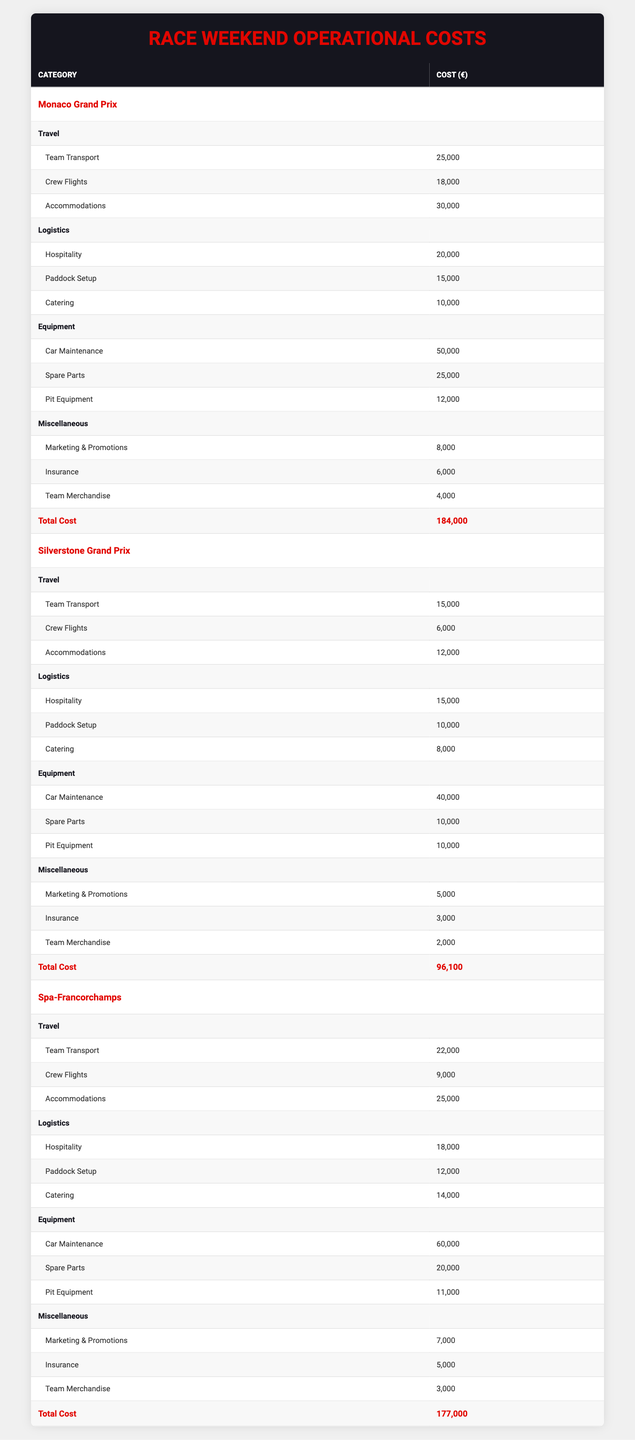What is the total cost for the Monaco Grand Prix? The total cost for the Monaco Grand Prix is listed in the table under the "Total Cost" row for that event, which shows 184000 euros.
Answer: 184000 euros What is the cost of crew flights for the Silverstone Grand Prix? The cost of crew flights is found in the "Travel" section for the Silverstone Grand Prix, and it is specifically listed as 6000 euros.
Answer: 6000 euros Which event has the highest total operational cost? By comparing the "Total Cost" values for each event, we see that the Monaco Grand Prix has the highest total at 184000 euros, while others are lower at 96100 euros and 177000 euros for the Silverstone Grand Prix and Spa-Francorchamps, respectively.
Answer: Monaco Grand Prix What is the combined cost for accommodations across all events? The accommodations costs are as follows: Monaco Grand Prix has 30000 euros, Silverstone Grand Prix has 12000 euros, and Spa-Francorchamps has 25000 euros. Adding these gives 30000 + 12000 + 25000 = 67000 euros for accommodations across all events.
Answer: 67000 euros Is the marketing and promotions cost for the Spa-Francorchamps higher than that for the Silverstone Grand Prix? The marketing and promotions cost for Spa-Francorchamps is 7000 euros, while for Silverstone Grand Prix, it is 5000 euros, indicating that Spa-Francorchamps has a higher cost.
Answer: Yes What is the average travel cost for all three events? To find the average travel cost, we first sum the travel costs: Monaco Grand Prix (25000 + 18000 + 30000 = 73000), Silverstone Grand Prix (15000 + 6000 + 12000 = 33000), and Spa-Francorchamps (22000 + 9000 + 25000 = 56000), giving a total of 73000 + 33000 + 56000 = 162000 euros. Dividing by 3 yields an average of 162000 / 3 = 54000 euros.
Answer: 54000 euros What is the total for "Logistics" costs in the Silverstone Grand Prix? The "Logistics" costs for Silverstone Grand Prix include Hospitality (15000 euros), Paddock Setup (10000 euros), and Catering (8000 euros). Summing these gives 15000 + 10000 + 8000 = 33000 euros for Logistics in the Silverstone Grand Prix.
Answer: 33000 euros Which event has the lowest cost for pit equipment? In the table, the costs for pit equipment are 12000 euros for Monaco, 10000 euros for Silverstone, and 11000 euros for Spa-Francorchamps. The lowest cost is therefore found in Silverstone Grand Prix at 10000 euros.
Answer: Silverstone Grand Prix Is the total cost of operational expenses for Spa-Francorchamps less than that of the Monaco Grand Prix? Comparing the total costs, Spa-Francorchamps is listed at 177000 euros and Monaco at 184000 euros, indicating that Spa-Francorchamps has a lesser total operational cost.
Answer: Yes 